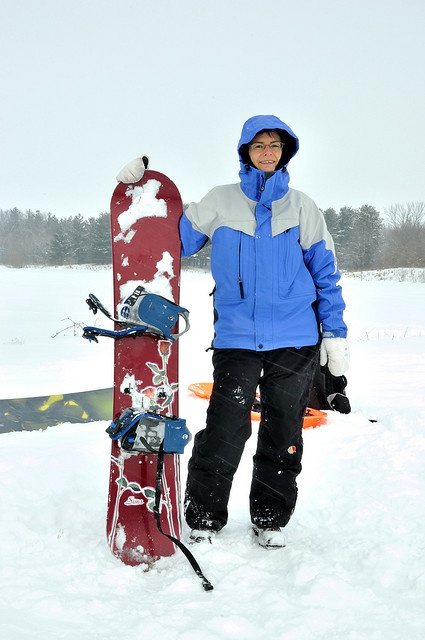Describe the objects in this image and their specific colors. I can see people in lightgray, black, and gray tones and snowboard in lightgray, white, brown, and maroon tones in this image. 